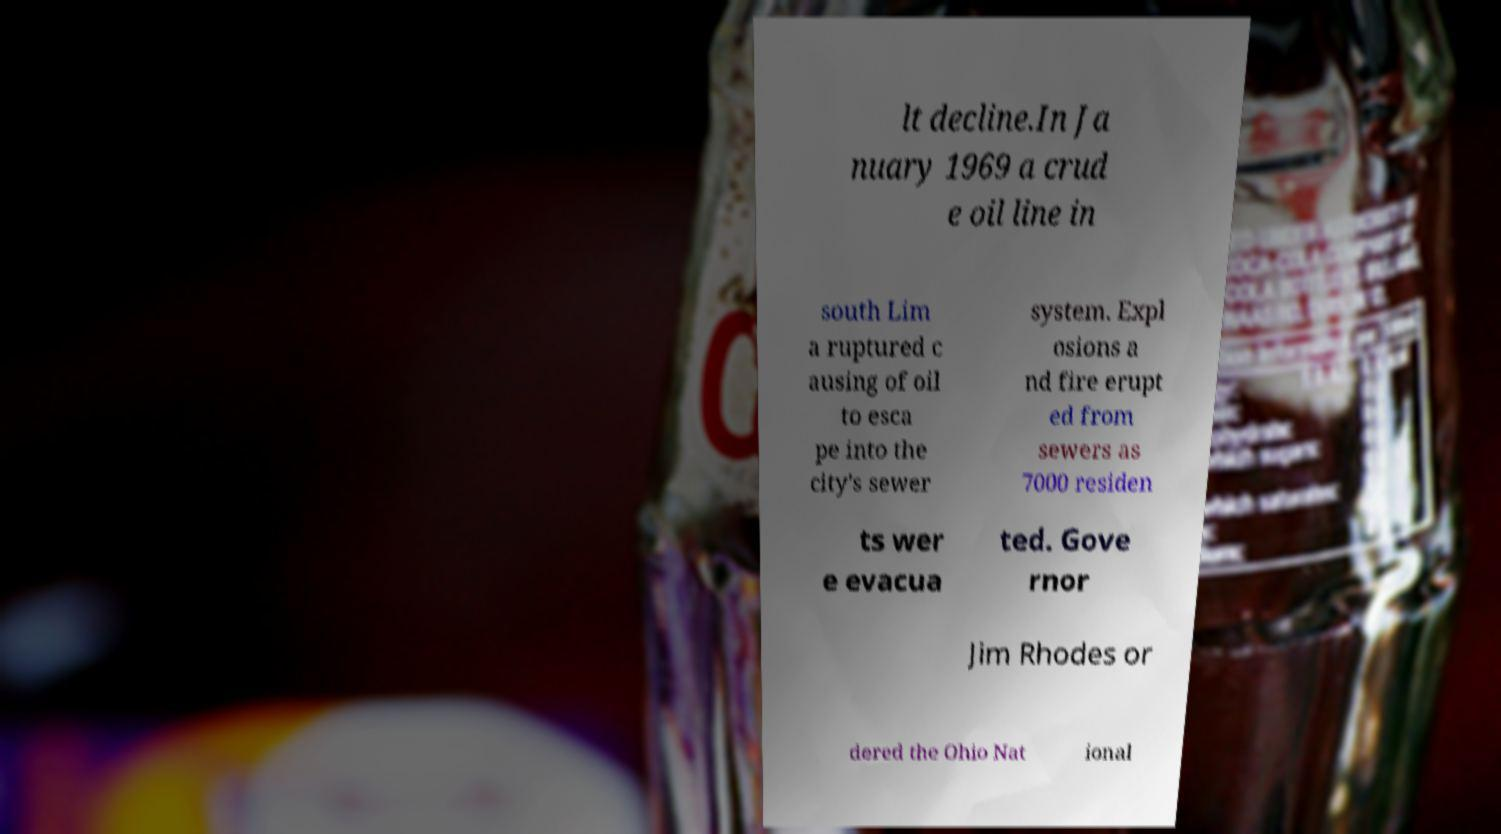For documentation purposes, I need the text within this image transcribed. Could you provide that? lt decline.In Ja nuary 1969 a crud e oil line in south Lim a ruptured c ausing of oil to esca pe into the city's sewer system. Expl osions a nd fire erupt ed from sewers as 7000 residen ts wer e evacua ted. Gove rnor Jim Rhodes or dered the Ohio Nat ional 